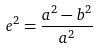<formula> <loc_0><loc_0><loc_500><loc_500>e ^ { 2 } = \frac { a ^ { 2 } - b ^ { 2 } } { a ^ { 2 } }</formula> 